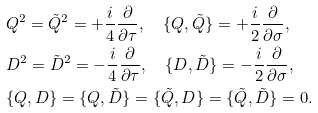<formula> <loc_0><loc_0><loc_500><loc_500>& Q ^ { 2 } = \tilde { Q } ^ { 2 } = + \frac { i } { 4 } \frac { \partial } { \partial \tau } , \quad \{ Q , \tilde { Q } \} = + \frac { i } { 2 } \frac { \partial } { \partial \sigma } , \\ & D ^ { 2 } = \tilde { D } ^ { 2 } = - \frac { i } { 4 } \frac { \partial } { \partial \tau } , \quad \{ D , \tilde { D } \} = - \frac { i } { 2 } \frac { \partial } { \partial \sigma } , \\ & \{ Q , D \} = \{ Q , \tilde { D } \} = \{ \tilde { Q } , D \} = \{ \tilde { Q } , \tilde { D } \} = 0 .</formula> 